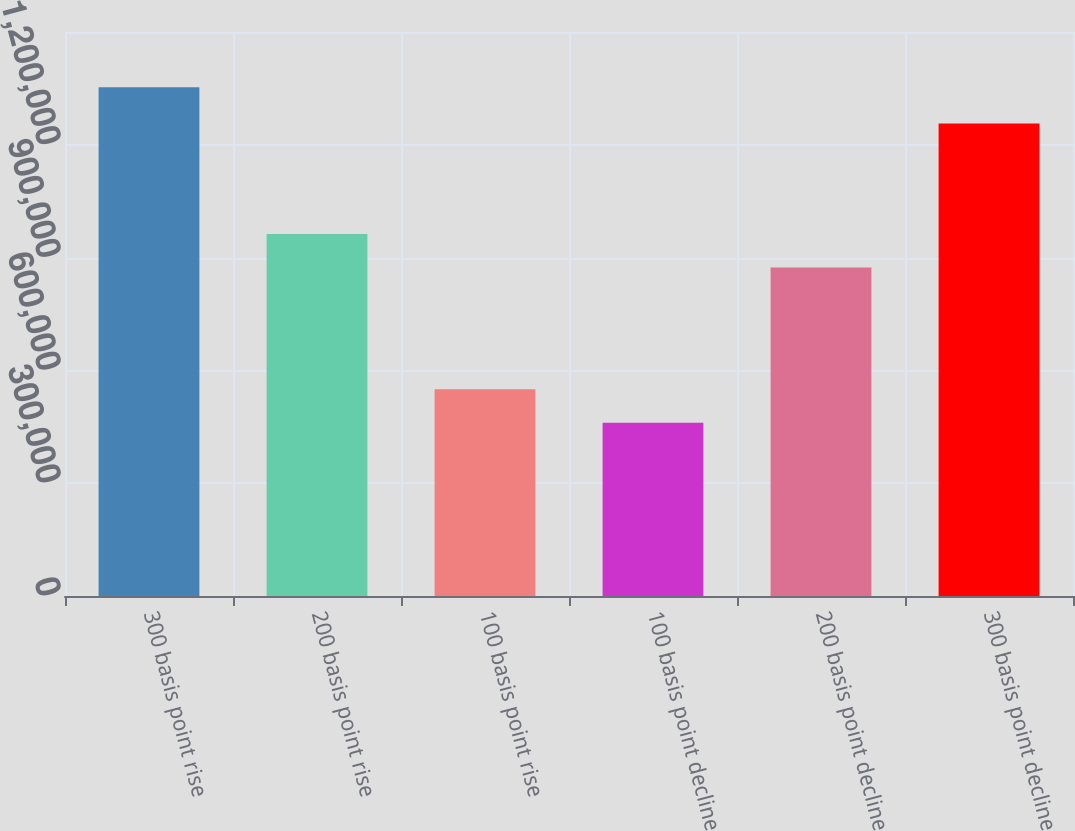Convert chart to OTSL. <chart><loc_0><loc_0><loc_500><loc_500><bar_chart><fcel>300 basis point rise<fcel>200 basis point rise<fcel>100 basis point rise<fcel>100 basis point decline<fcel>200 basis point decline<fcel>300 basis point decline<nl><fcel>1.35277e+06<fcel>963069<fcel>549831<fcel>460615<fcel>873853<fcel>1.25653e+06<nl></chart> 